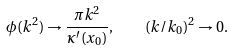<formula> <loc_0><loc_0><loc_500><loc_500>\phi ( k ^ { 2 } ) \rightarrow \frac { \pi k ^ { 2 } } { \kappa ^ { \prime } ( x _ { 0 } ) } , \quad ( k / k _ { 0 } ) ^ { 2 } \rightarrow 0 .</formula> 